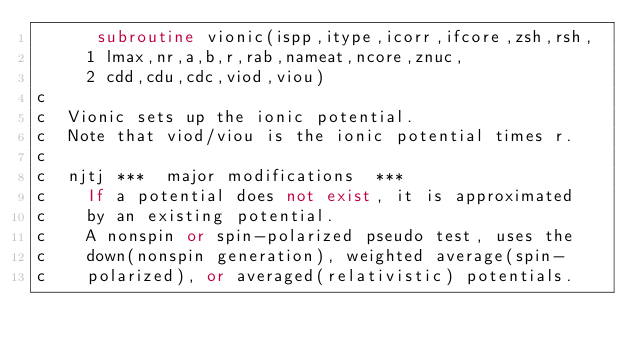<code> <loc_0><loc_0><loc_500><loc_500><_FORTRAN_>      subroutine vionic(ispp,itype,icorr,ifcore,zsh,rsh,
     1 lmax,nr,a,b,r,rab,nameat,ncore,znuc,
     2 cdd,cdu,cdc,viod,viou)
c
c  Vionic sets up the ionic potential.
c  Note that viod/viou is the ionic potential times r.
c
c  njtj ***  major modifications  ***
c    If a potential does not exist, it is approximated
c    by an existing potential.
c    A nonspin or spin-polarized pseudo test, uses the 
c    down(nonspin generation), weighted average(spin-
c    polarized), or averaged(relativistic) potentials.</code> 